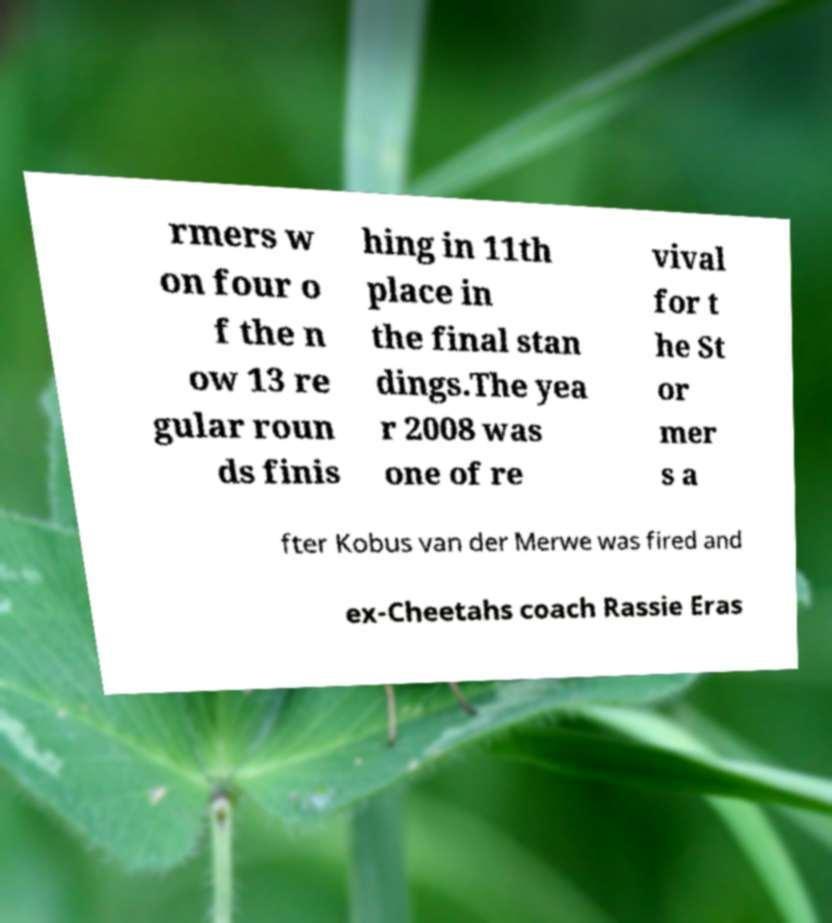For documentation purposes, I need the text within this image transcribed. Could you provide that? rmers w on four o f the n ow 13 re gular roun ds finis hing in 11th place in the final stan dings.The yea r 2008 was one of re vival for t he St or mer s a fter Kobus van der Merwe was fired and ex-Cheetahs coach Rassie Eras 